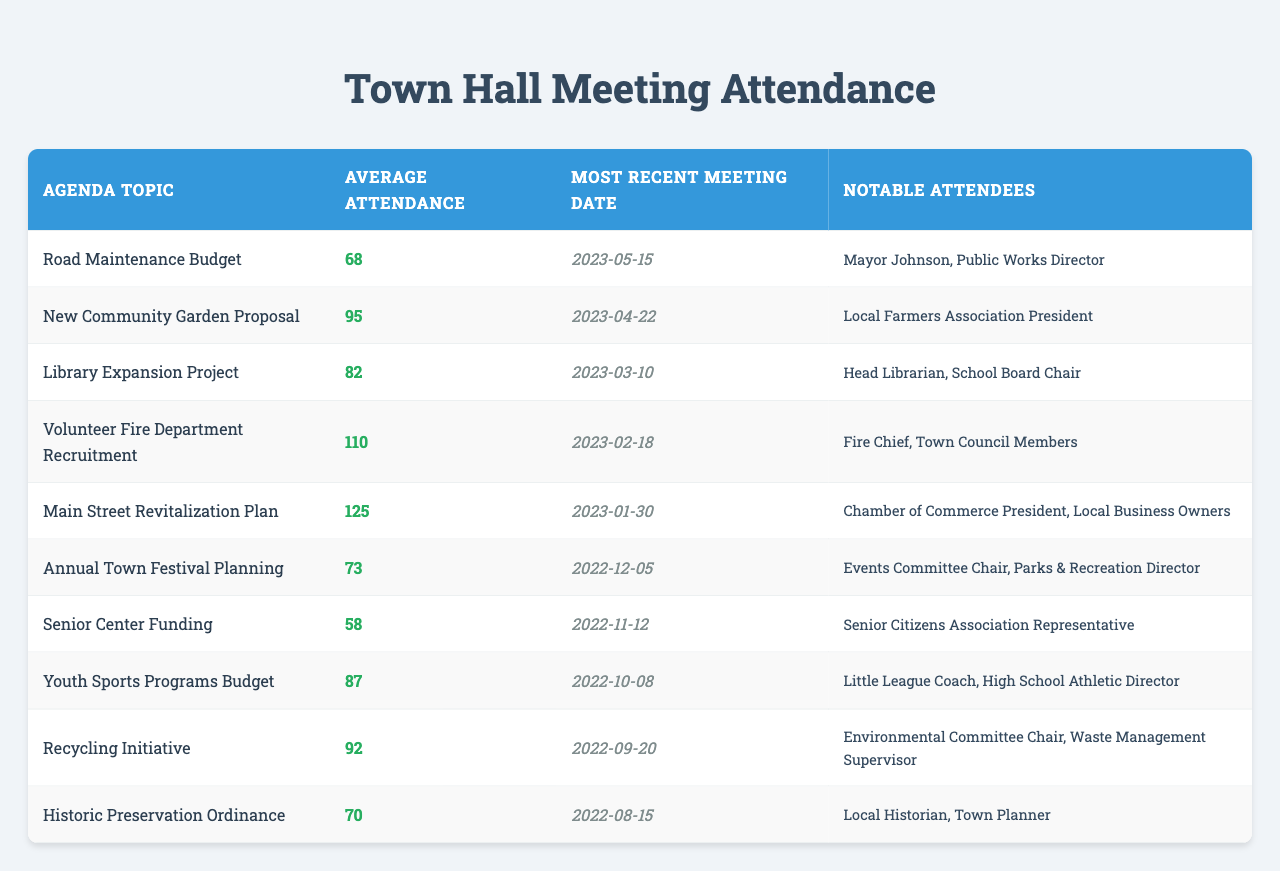What was the highest average attendance at a town hall meeting? The highest average attendance recorded in the table is for the "Main Street Revitalization Plan" with an attendance of 125.
Answer: 125 Which agenda topic had the least average attendance? The "Senior Center Funding" agenda topic had the least average attendance at 58.
Answer: 58 What is the average attendance for all meetings? To calculate the average, we first sum the average attendance values: 68 + 95 + 82 + 110 + 125 + 73 + 58 + 87 + 92 + 70 = 990. Since there are 10 topics, the average is 990 / 10 = 99.
Answer: 99 Is there a meeting with average attendance over 100? Yes, there are meetings with average attendance over 100, specifically for "Volunteer Fire Department Recruitment" with 110 and "Main Street Revitalization Plan" with 125.
Answer: Yes Which meeting date was the most recent for the "Library Expansion Project"? The most recent meeting date for the "Library Expansion Project" was 2023-03-10.
Answer: 2023-03-10 How many agenda topics had notable attendees from local officials? From the table, the notable attendees from local officials are present in the following topics: "Road Maintenance Budget," "Library Expansion Project," "Volunteer Fire Department Recruitment," "Main Street Revitalization Plan," and "Youth Sports Programs Budget," totaling to 5 topics.
Answer: 5 What are the notable attendees for the "Recycling Initiative"? The notable attendees for the "Recycling Initiative" are the Environmental Committee Chair and the Waste Management Supervisor.
Answer: Environmental Committee Chair, Waste Management Supervisor What is the difference in average attendance between the "New Community Garden Proposal" and the "Historic Preservation Ordinance"? The average attendance for "New Community Garden Proposal" is 95 and for "Historic Preservation Ordinance" is 70. The difference is 95 - 70 = 25.
Answer: 25 Did attendance generally increase for topics discussed at the beginning of the year compared to later topics? To determine this, we can compare average attendances: “Main Street Revitalization Plan” (125), “Volunteer Fire Department Recruitment” (110), “Library Expansion Project” (82) and analyze them against topics later in the year like “Annual Town Festival Planning” (73) and “Senior Center Funding” (58). The attendance does generally decline towards the year’s end.
Answer: Yes What percentage of the total attendance was for "Volunteer Fire Department Recruitment"? The total attendance is 990. The attendance for "Volunteer Fire Department Recruitment" is 110. The percentage is (110 / 990) * 100 = 11.11%.
Answer: 11.11% 